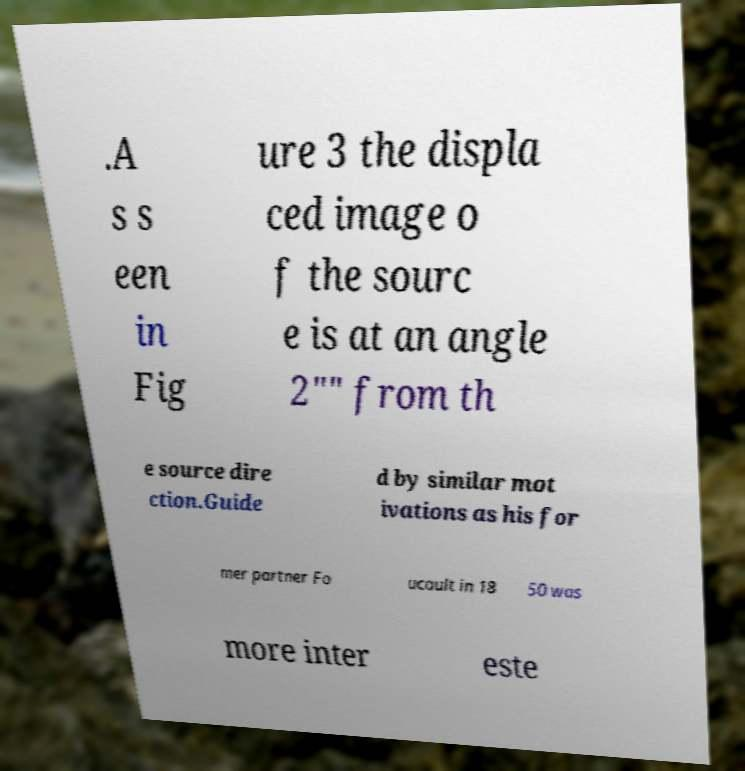Please read and relay the text visible in this image. What does it say? .A s s een in Fig ure 3 the displa ced image o f the sourc e is at an angle 2"" from th e source dire ction.Guide d by similar mot ivations as his for mer partner Fo ucault in 18 50 was more inter este 